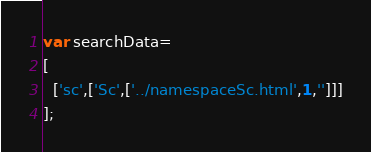Convert code to text. <code><loc_0><loc_0><loc_500><loc_500><_JavaScript_>var searchData=
[
  ['sc',['Sc',['../namespaceSc.html',1,'']]]
];
</code> 